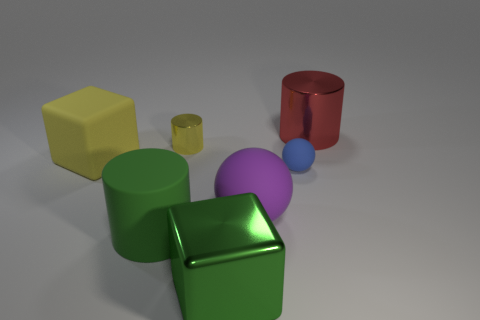What size is the purple rubber sphere?
Provide a short and direct response. Large. There is a tiny yellow thing; what shape is it?
Your answer should be very brief. Cylinder. There is a large green metallic object; does it have the same shape as the big rubber object that is behind the tiny blue sphere?
Your answer should be compact. Yes. There is a small thing that is on the left side of the big green block; is it the same shape as the blue rubber thing?
Your response must be concise. No. What number of large cylinders are both to the right of the blue thing and to the left of the big red cylinder?
Give a very brief answer. 0. What number of other things are there of the same size as the metal block?
Keep it short and to the point. 4. Are there an equal number of large cylinders that are left of the large yellow cube and big gray matte objects?
Provide a succinct answer. Yes. Do the shiny cylinder left of the red cylinder and the block in front of the matte cube have the same color?
Keep it short and to the point. No. What is the material of the object that is left of the small matte sphere and behind the matte block?
Your response must be concise. Metal. The matte cube is what color?
Your response must be concise. Yellow. 